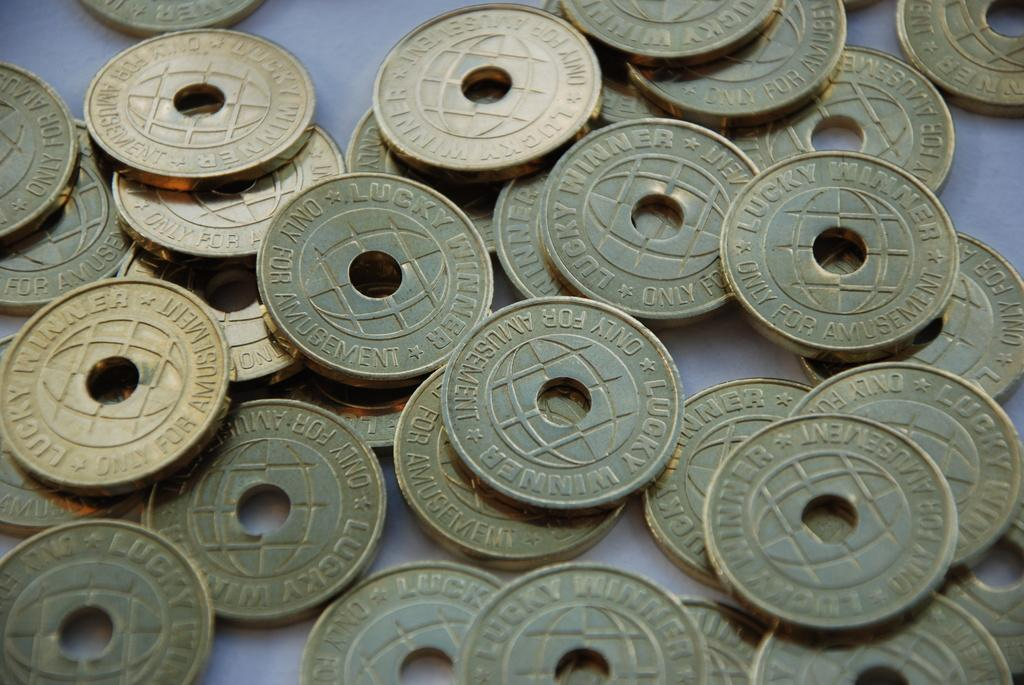<image>
Relay a brief, clear account of the picture shown. Tokens with holes in the middle and the words only for visible. 